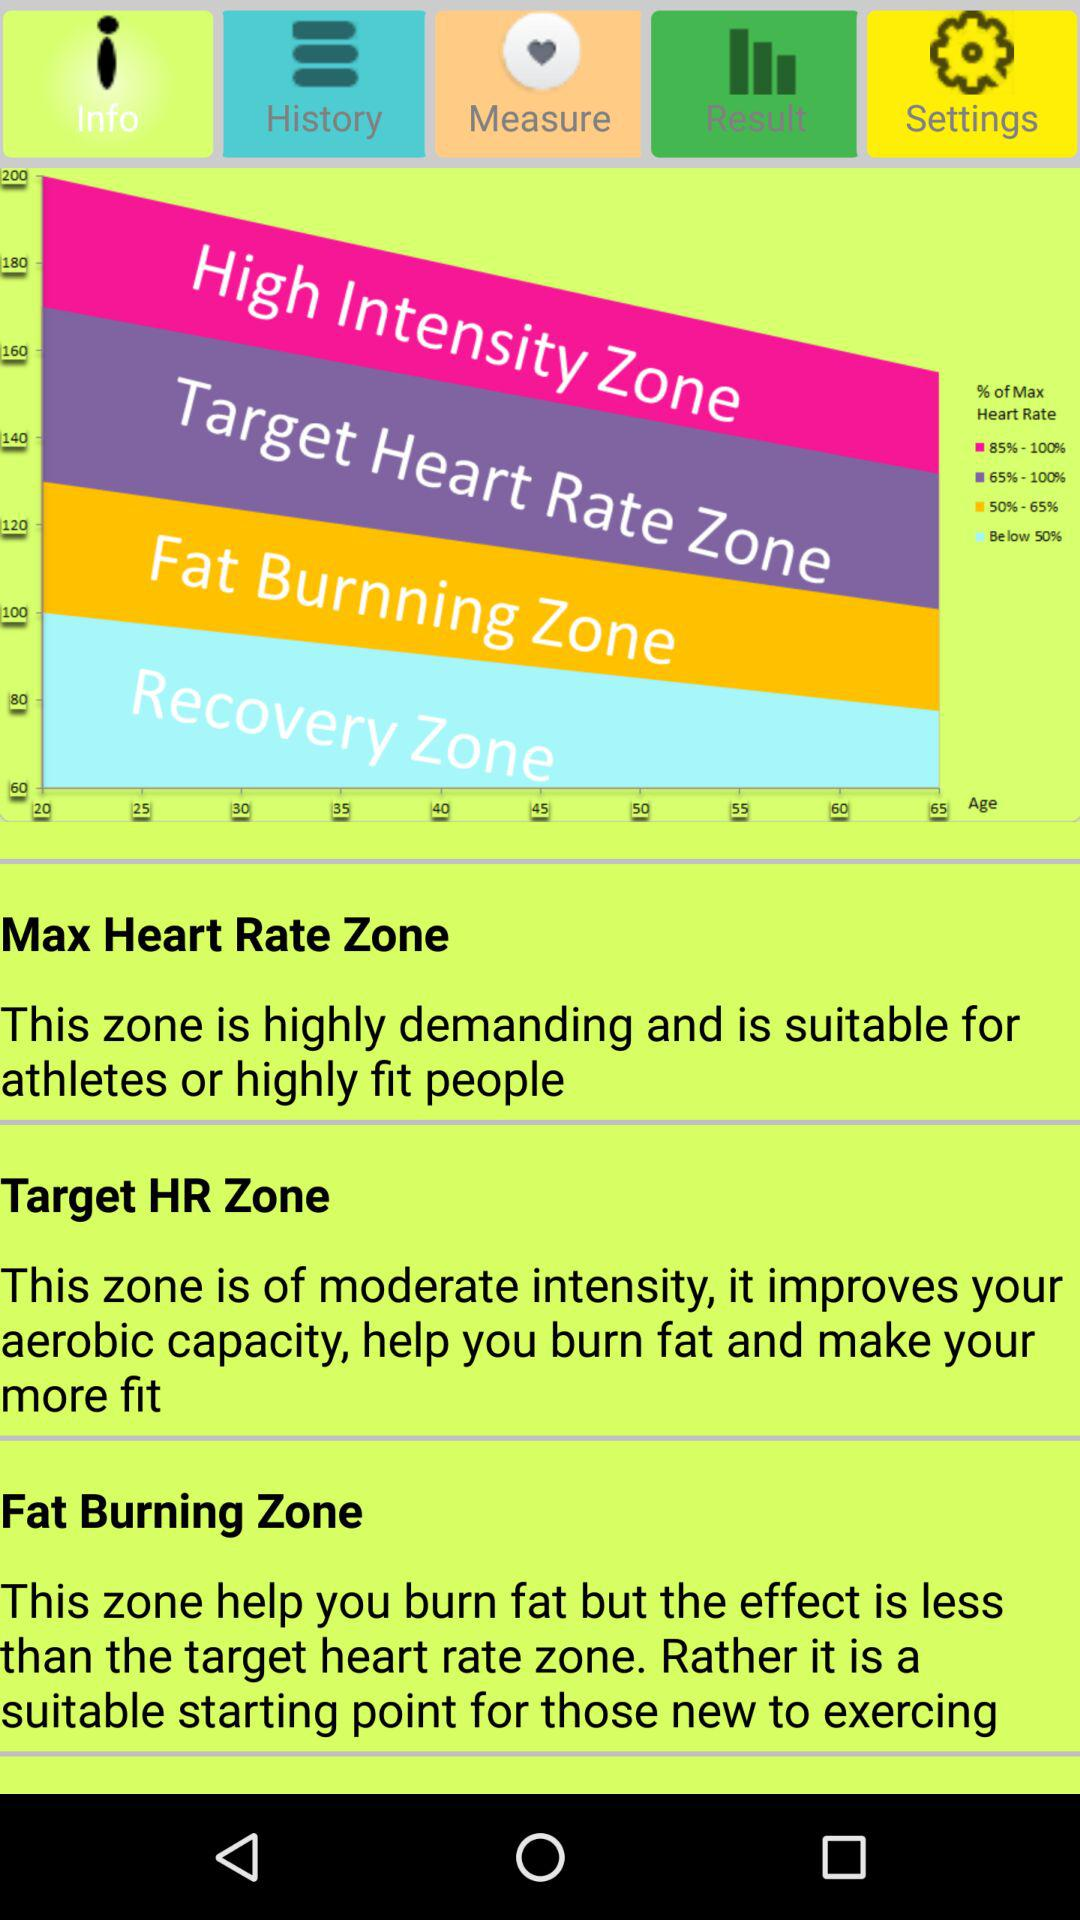Which tab is selected? The selected tab is "Info". 